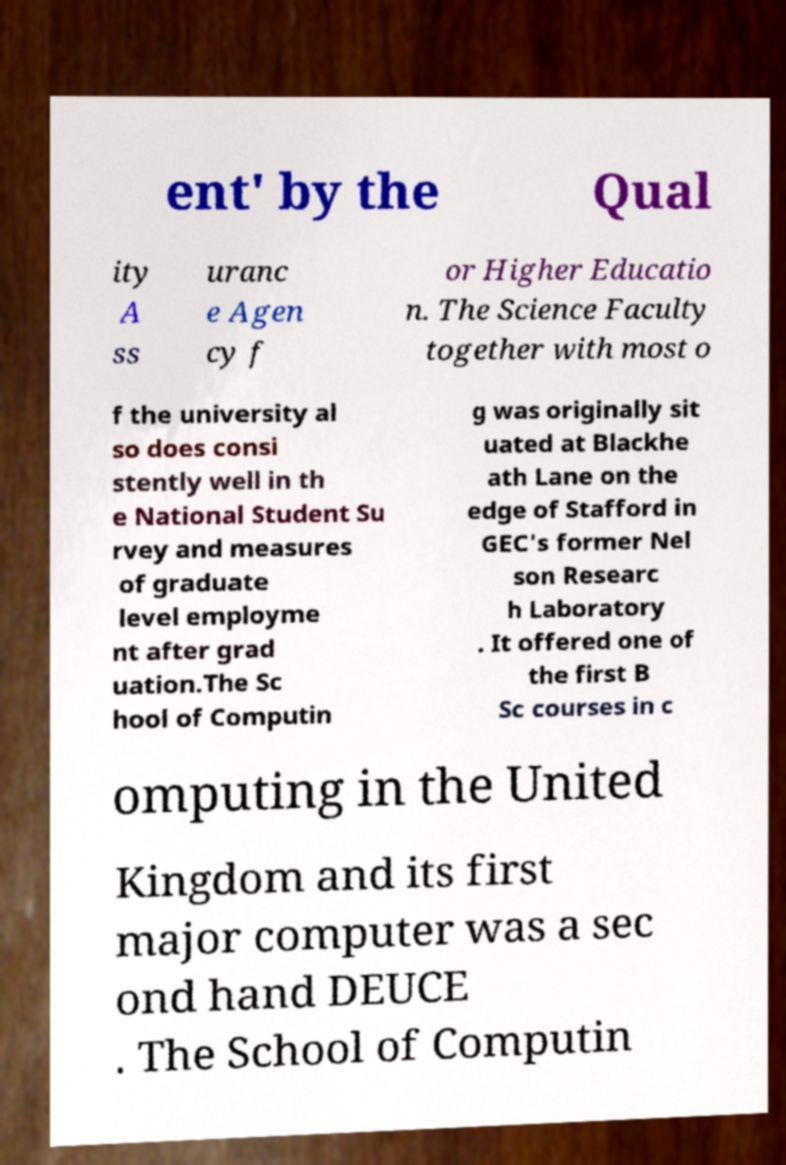Can you read and provide the text displayed in the image?This photo seems to have some interesting text. Can you extract and type it out for me? ent' by the Qual ity A ss uranc e Agen cy f or Higher Educatio n. The Science Faculty together with most o f the university al so does consi stently well in th e National Student Su rvey and measures of graduate level employme nt after grad uation.The Sc hool of Computin g was originally sit uated at Blackhe ath Lane on the edge of Stafford in GEC's former Nel son Researc h Laboratory . It offered one of the first B Sc courses in c omputing in the United Kingdom and its first major computer was a sec ond hand DEUCE . The School of Computin 